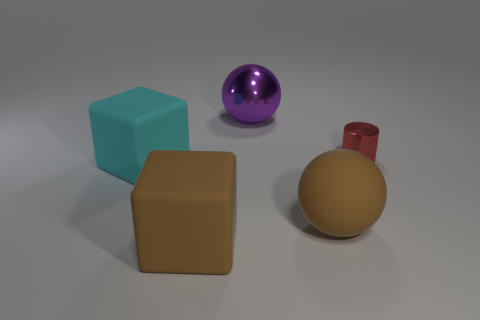Subtract all balls. How many objects are left? 3 Add 4 tiny purple rubber spheres. How many objects exist? 9 Subtract 0 cyan spheres. How many objects are left? 5 Subtract all red objects. Subtract all small gray shiny cubes. How many objects are left? 4 Add 3 brown balls. How many brown balls are left? 4 Add 4 large cyan cubes. How many large cyan cubes exist? 5 